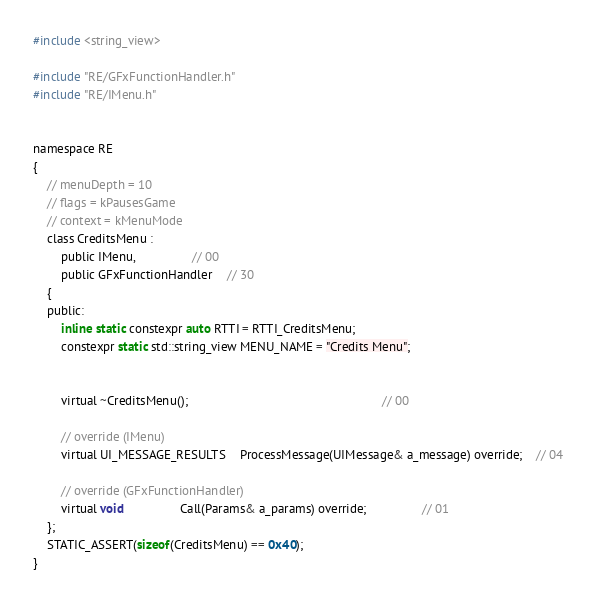<code> <loc_0><loc_0><loc_500><loc_500><_C_>
#include <string_view>

#include "RE/GFxFunctionHandler.h"
#include "RE/IMenu.h"


namespace RE
{
	// menuDepth = 10
	// flags = kPausesGame
	// context = kMenuMode
	class CreditsMenu :
		public IMenu,				// 00
		public GFxFunctionHandler	// 30
	{
	public:
		inline static constexpr auto RTTI = RTTI_CreditsMenu;
		constexpr static std::string_view MENU_NAME = "Credits Menu";


		virtual ~CreditsMenu();														// 00

		// override (IMenu)
		virtual UI_MESSAGE_RESULTS	ProcessMessage(UIMessage& a_message) override;	// 04

		// override (GFxFunctionHandler)
		virtual void				Call(Params& a_params) override;				// 01
	};
	STATIC_ASSERT(sizeof(CreditsMenu) == 0x40);
}
</code> 